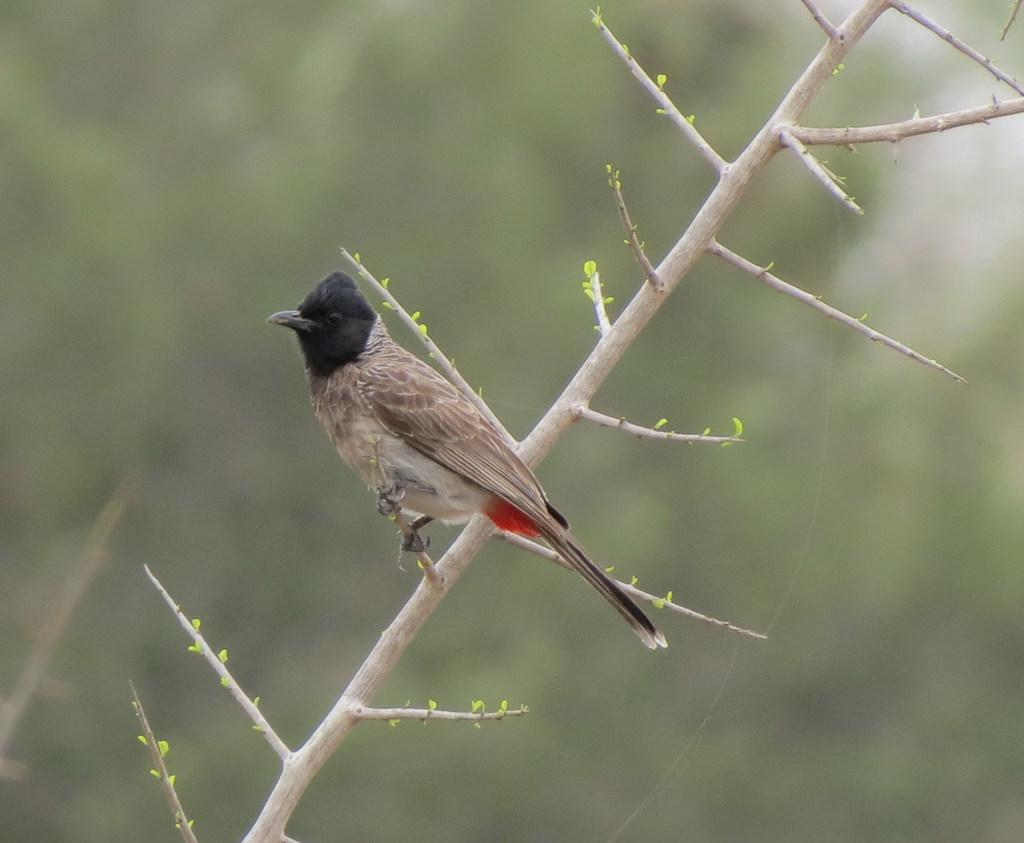What type of animal is in the image? There is a bird in the image. Where is the bird located? The bird is sitting on a branch. What is the branch a part of? The branch is part of a tree. What type of zinc is visible on the wall in the image? There is no zinc or wall present in the image; it features a bird sitting on a branch of a tree. 